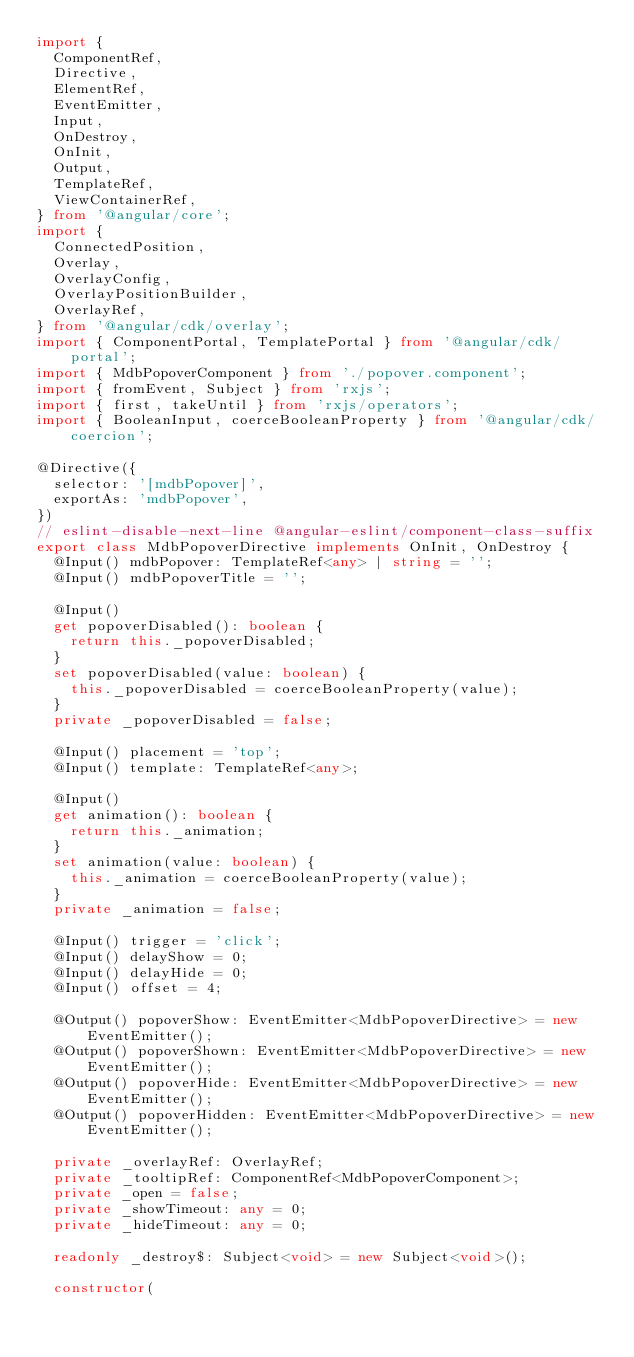<code> <loc_0><loc_0><loc_500><loc_500><_TypeScript_>import {
  ComponentRef,
  Directive,
  ElementRef,
  EventEmitter,
  Input,
  OnDestroy,
  OnInit,
  Output,
  TemplateRef,
  ViewContainerRef,
} from '@angular/core';
import {
  ConnectedPosition,
  Overlay,
  OverlayConfig,
  OverlayPositionBuilder,
  OverlayRef,
} from '@angular/cdk/overlay';
import { ComponentPortal, TemplatePortal } from '@angular/cdk/portal';
import { MdbPopoverComponent } from './popover.component';
import { fromEvent, Subject } from 'rxjs';
import { first, takeUntil } from 'rxjs/operators';
import { BooleanInput, coerceBooleanProperty } from '@angular/cdk/coercion';

@Directive({
  selector: '[mdbPopover]',
  exportAs: 'mdbPopover',
})
// eslint-disable-next-line @angular-eslint/component-class-suffix
export class MdbPopoverDirective implements OnInit, OnDestroy {
  @Input() mdbPopover: TemplateRef<any> | string = '';
  @Input() mdbPopoverTitle = '';

  @Input()
  get popoverDisabled(): boolean {
    return this._popoverDisabled;
  }
  set popoverDisabled(value: boolean) {
    this._popoverDisabled = coerceBooleanProperty(value);
  }
  private _popoverDisabled = false;

  @Input() placement = 'top';
  @Input() template: TemplateRef<any>;

  @Input()
  get animation(): boolean {
    return this._animation;
  }
  set animation(value: boolean) {
    this._animation = coerceBooleanProperty(value);
  }
  private _animation = false;

  @Input() trigger = 'click';
  @Input() delayShow = 0;
  @Input() delayHide = 0;
  @Input() offset = 4;

  @Output() popoverShow: EventEmitter<MdbPopoverDirective> = new EventEmitter();
  @Output() popoverShown: EventEmitter<MdbPopoverDirective> = new EventEmitter();
  @Output() popoverHide: EventEmitter<MdbPopoverDirective> = new EventEmitter();
  @Output() popoverHidden: EventEmitter<MdbPopoverDirective> = new EventEmitter();

  private _overlayRef: OverlayRef;
  private _tooltipRef: ComponentRef<MdbPopoverComponent>;
  private _open = false;
  private _showTimeout: any = 0;
  private _hideTimeout: any = 0;

  readonly _destroy$: Subject<void> = new Subject<void>();

  constructor(</code> 